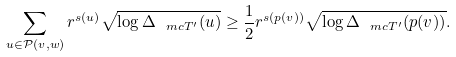Convert formula to latex. <formula><loc_0><loc_0><loc_500><loc_500>\sum _ { u \in \mathcal { P } ( v , w ) } r ^ { s ( u ) } \sqrt { \log \Delta _ { \ m c T ^ { \prime } } ( u ) } \geq \frac { 1 } { 2 } r ^ { s ( p ( v ) ) } \sqrt { \log \Delta _ { \ m c T ^ { \prime } } ( p ( v ) ) } .</formula> 